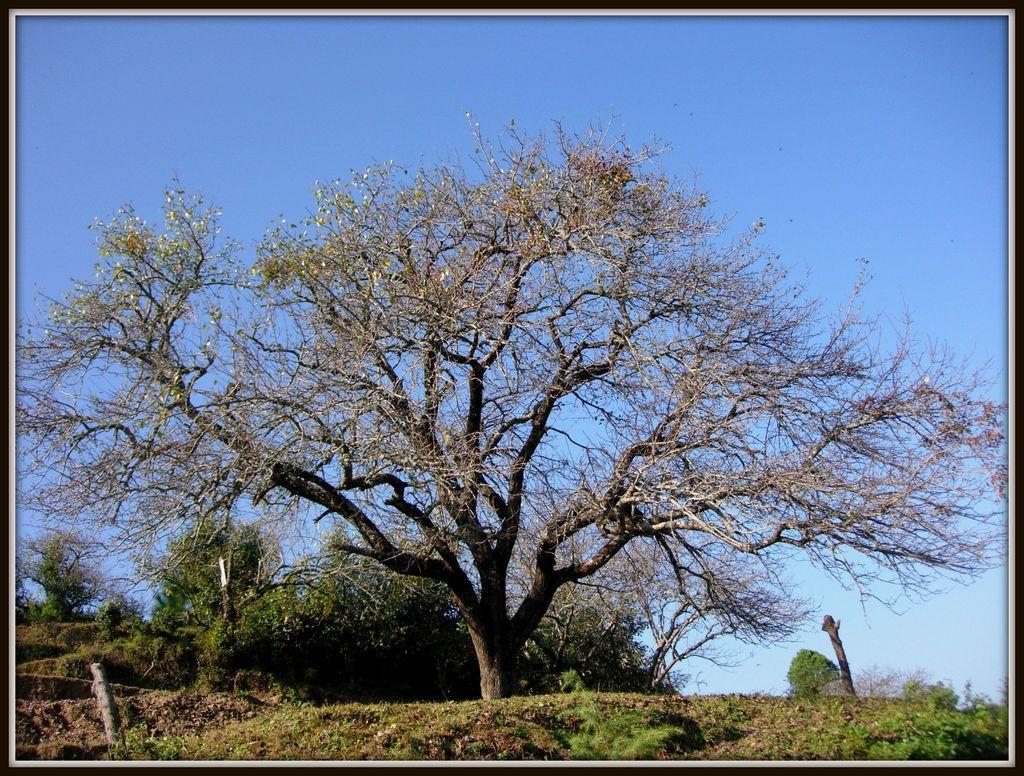How would you summarize this image in a sentence or two? In this image we can see a group of trees, plants, grass, some wooden poles and the sky which looks cloudy. 